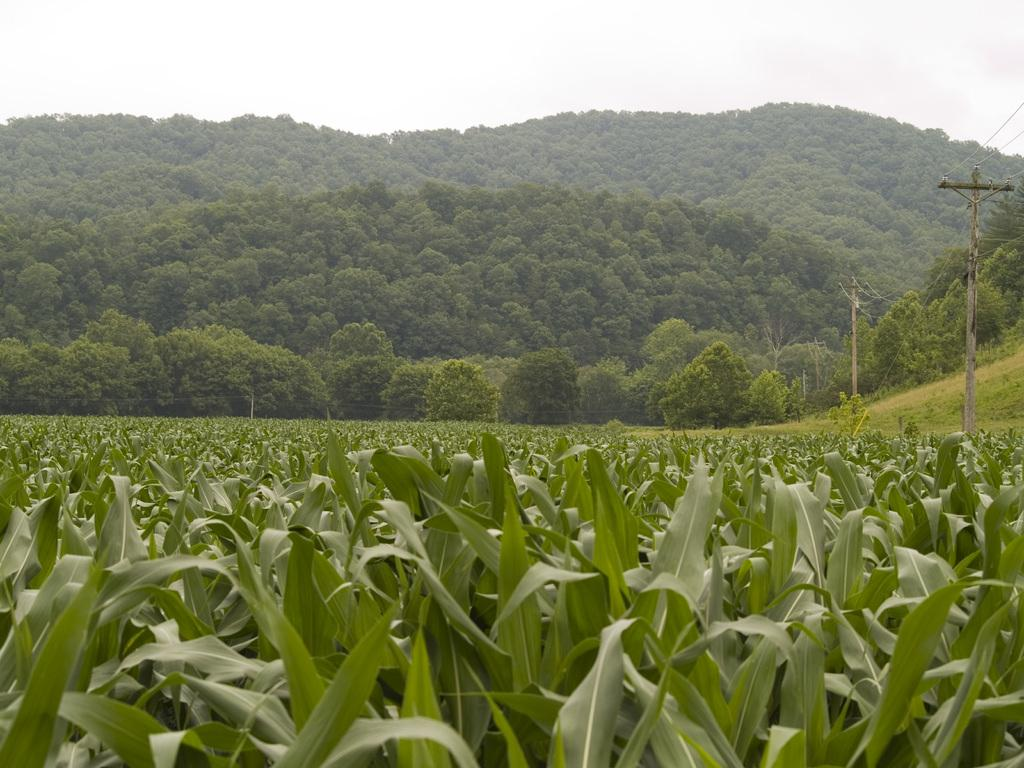What type of living organisms can be seen in the image? Plants can be seen in the image. What structures are visible in the background of the image? Electric poles and trees are visible in the background of the image. What part of the natural environment is visible in the image? The sky is visible in the background of the image. What type of chess piece is located on the roof of the building in the image? There is no chess piece or building present in the image. What type of beam is supporting the roof of the home in the image? There is no home or beam present in the image. 